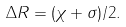Convert formula to latex. <formula><loc_0><loc_0><loc_500><loc_500>\Delta R = ( \chi + \sigma ) / 2 .</formula> 